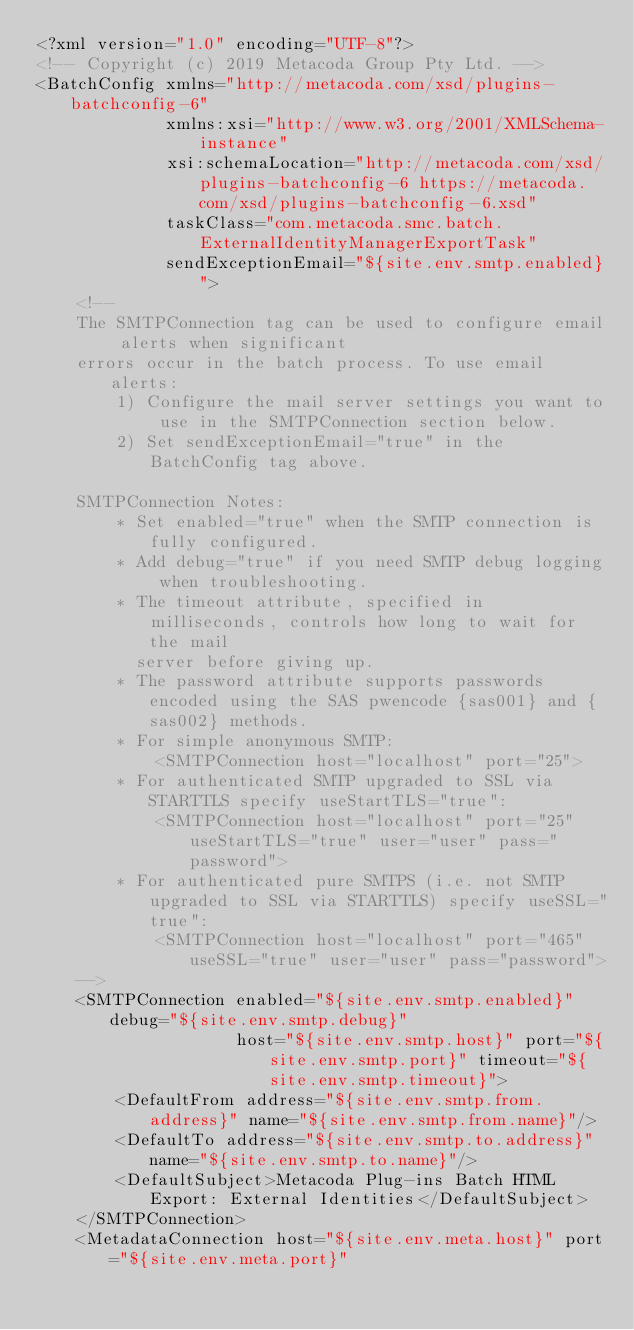Convert code to text. <code><loc_0><loc_0><loc_500><loc_500><_XML_><?xml version="1.0" encoding="UTF-8"?>
<!-- Copyright (c) 2019 Metacoda Group Pty Ltd. -->
<BatchConfig xmlns="http://metacoda.com/xsd/plugins-batchconfig-6"
             xmlns:xsi="http://www.w3.org/2001/XMLSchema-instance"
             xsi:schemaLocation="http://metacoda.com/xsd/plugins-batchconfig-6 https://metacoda.com/xsd/plugins-batchconfig-6.xsd"
             taskClass="com.metacoda.smc.batch.ExternalIdentityManagerExportTask"
             sendExceptionEmail="${site.env.smtp.enabled}">
    <!--
    The SMTPConnection tag can be used to configure email alerts when significant
    errors occur in the batch process. To use email alerts:
        1) Configure the mail server settings you want to use in the SMTPConnection section below.
        2) Set sendExceptionEmail="true" in the BatchConfig tag above.

    SMTPConnection Notes:
        * Set enabled="true" when the SMTP connection is fully configured.
        * Add debug="true" if you need SMTP debug logging when troubleshooting.
        * The timeout attribute, specified in milliseconds, controls how long to wait for the mail
          server before giving up.
        * The password attribute supports passwords encoded using the SAS pwencode {sas001} and {sas002} methods.
        * For simple anonymous SMTP:
            <SMTPConnection host="localhost" port="25">
        * For authenticated SMTP upgraded to SSL via STARTTLS specify useStartTLS="true":
            <SMTPConnection host="localhost" port="25" useStartTLS="true" user="user" pass="password">
        * For authenticated pure SMTPS (i.e. not SMTP upgraded to SSL via STARTTLS) specify useSSL="true":
            <SMTPConnection host="localhost" port="465" useSSL="true" user="user" pass="password">
    -->
    <SMTPConnection enabled="${site.env.smtp.enabled}" debug="${site.env.smtp.debug}"
                    host="${site.env.smtp.host}" port="${site.env.smtp.port}" timeout="${site.env.smtp.timeout}">
        <DefaultFrom address="${site.env.smtp.from.address}" name="${site.env.smtp.from.name}"/>
        <DefaultTo address="${site.env.smtp.to.address}" name="${site.env.smtp.to.name}"/>
        <DefaultSubject>Metacoda Plug-ins Batch HTML Export: External Identities</DefaultSubject>
    </SMTPConnection>
    <MetadataConnection host="${site.env.meta.host}" port="${site.env.meta.port}"</code> 